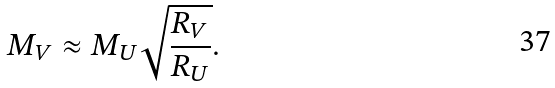<formula> <loc_0><loc_0><loc_500><loc_500>M _ { V } \approx M _ { U } \sqrt { \frac { R _ { V } } { R _ { U } } } .</formula> 